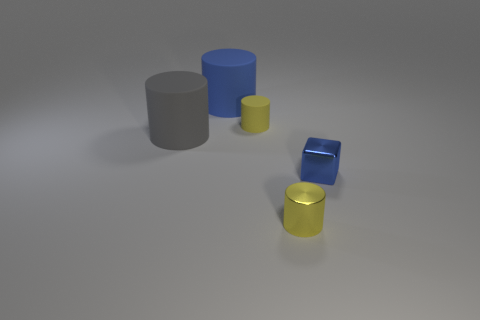Add 1 gray things. How many objects exist? 6 Subtract all cylinders. How many objects are left? 1 Subtract 0 purple balls. How many objects are left? 5 Subtract all metallic cylinders. Subtract all yellow shiny objects. How many objects are left? 3 Add 2 tiny blue things. How many tiny blue things are left? 3 Add 4 small objects. How many small objects exist? 7 